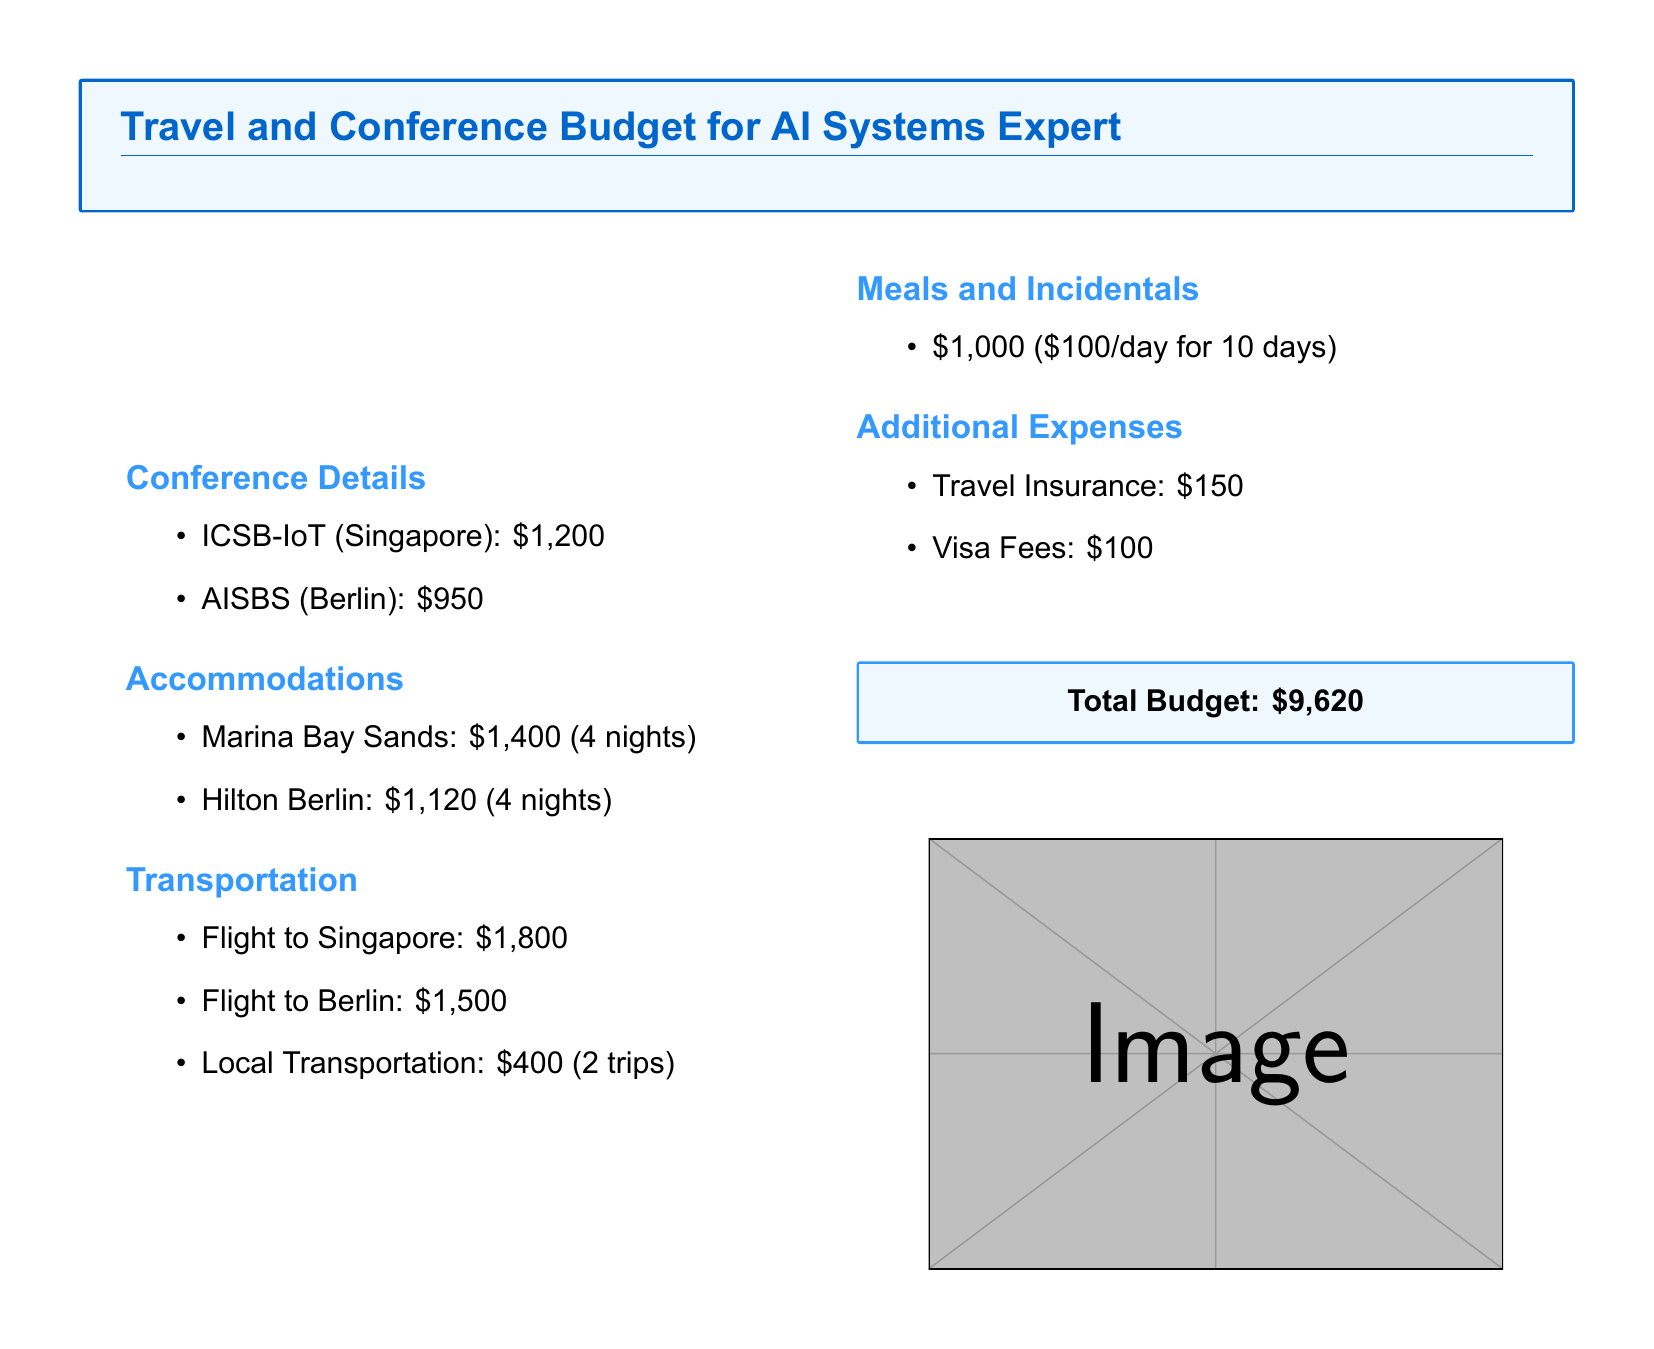What is the total budget? The total budget is stated in a specific section of the document that sums up all expenses, which is $9,620.
Answer: $9,620 What is the registration fee for AISBS? The registration fee for AISBS is explicitly listed in the conference details section, which is $950.
Answer: $950 How many nights is Marina Bay Sands booked for? The number of nights for Marina Bay Sands is mentioned alongside its cost in the accommodations section, which is 4 nights.
Answer: 4 nights What is the cost of local transportation? The cost for local transportation is stated directly in the transportation section, which is $400 for 2 trips.
Answer: $400 What is the total cost for accommodations? The total cost can be calculated by adding the accommodations listed for both hotels, which is $1,400 + $1,120 = $2,520.
Answer: $2,520 What is the amount allocated for meals and incidentals? The allocated amount for meals and incidentals is clearly mentioned in the document, which is $1,000 for 10 days.
Answer: $1,000 What additional expense is listed after meals? The additional expenses following meals are travel insurance and visa fees, explicitly stating their respective costs.
Answer: Travel Insurance How much is allocated for visa fees? The cost for visa fees is specifically mentioned as part of additional expenses, which is $100.
Answer: $100 What is the cost of a flight to Berlin? The cost of the flight to Berlin is directly provided in the transportation section, which is $1,500.
Answer: $1,500 